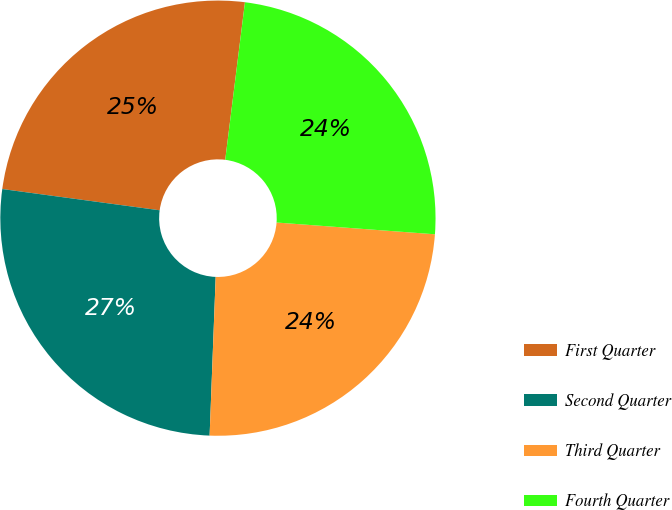<chart> <loc_0><loc_0><loc_500><loc_500><pie_chart><fcel>First Quarter<fcel>Second Quarter<fcel>Third Quarter<fcel>Fourth Quarter<nl><fcel>24.85%<fcel>26.53%<fcel>24.43%<fcel>24.2%<nl></chart> 